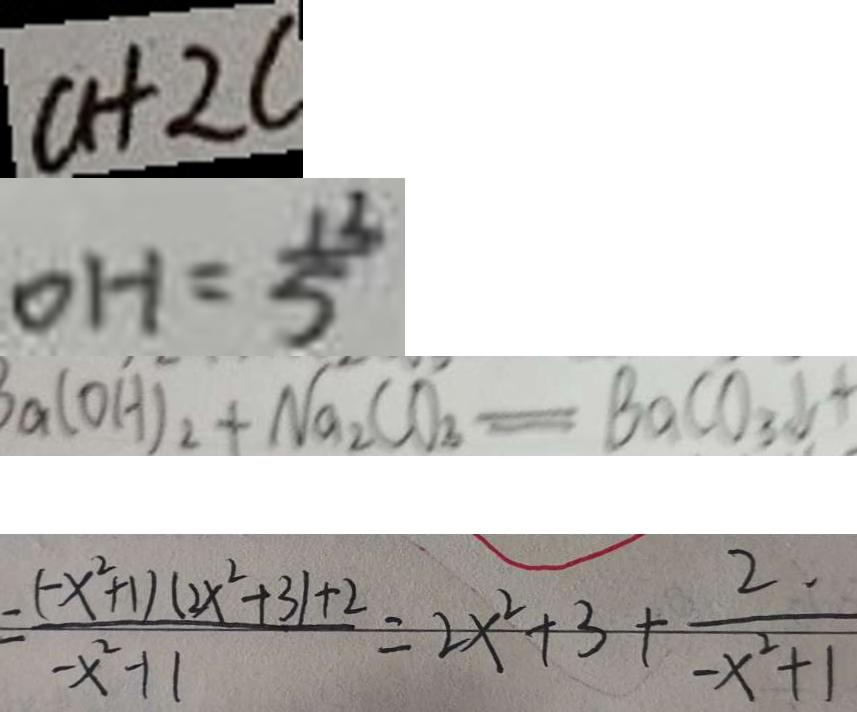<formula> <loc_0><loc_0><loc_500><loc_500>a + 2 c 
 0 H = \frac { 1 3 } { 5 } 
 a ( O H ) _ { 2 } + N a _ { 2 } C O _ { 3 } = B a C O _ { 3 } \downarrow + 
 = \frac { - ( - x ^ { 2 } + 1 ) ( 2 x ^ { 2 } + 3 ) + 2 } { - x ^ { 2 } + 1 } = 2 x ^ { 2 } + 3 + \frac { 2 . } { - x ^ { 2 } + 1 }</formula> 